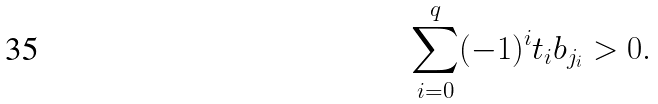<formula> <loc_0><loc_0><loc_500><loc_500>\sum _ { i = 0 } ^ { q } ( - 1 ) ^ { i } t _ { i } b _ { j _ { i } } > 0 .</formula> 